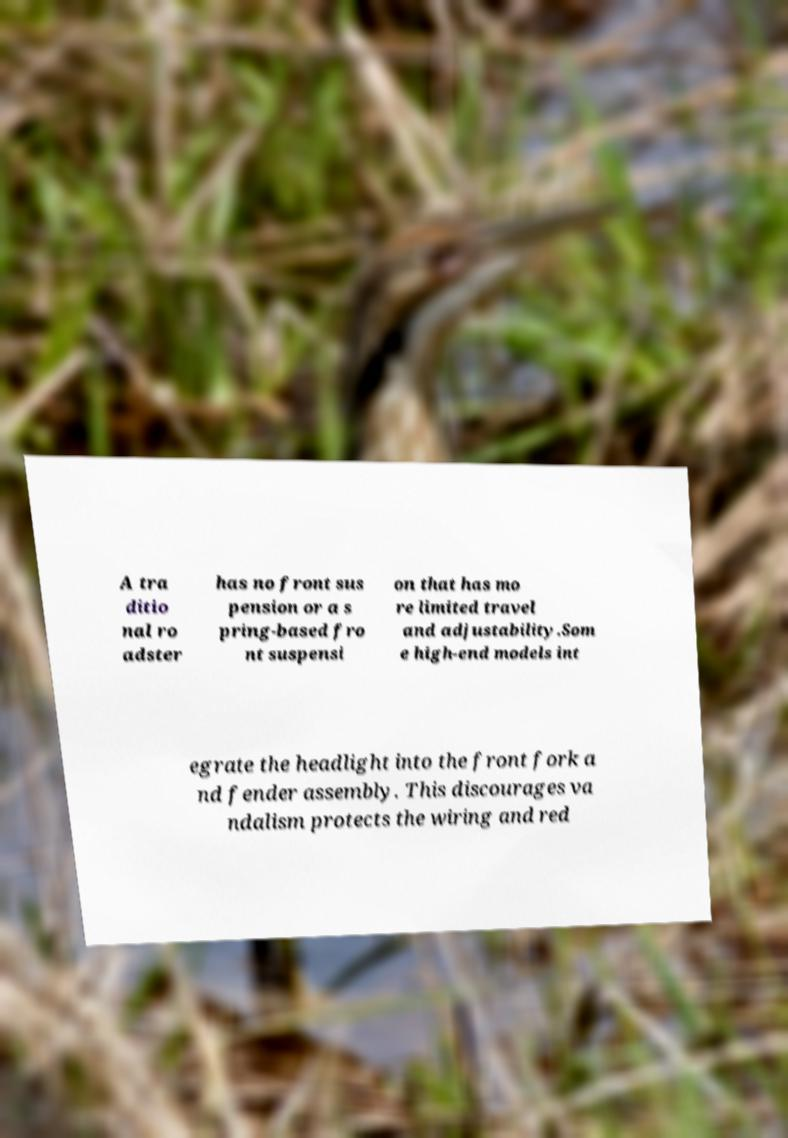Can you accurately transcribe the text from the provided image for me? A tra ditio nal ro adster has no front sus pension or a s pring-based fro nt suspensi on that has mo re limited travel and adjustability.Som e high-end models int egrate the headlight into the front fork a nd fender assembly. This discourages va ndalism protects the wiring and red 